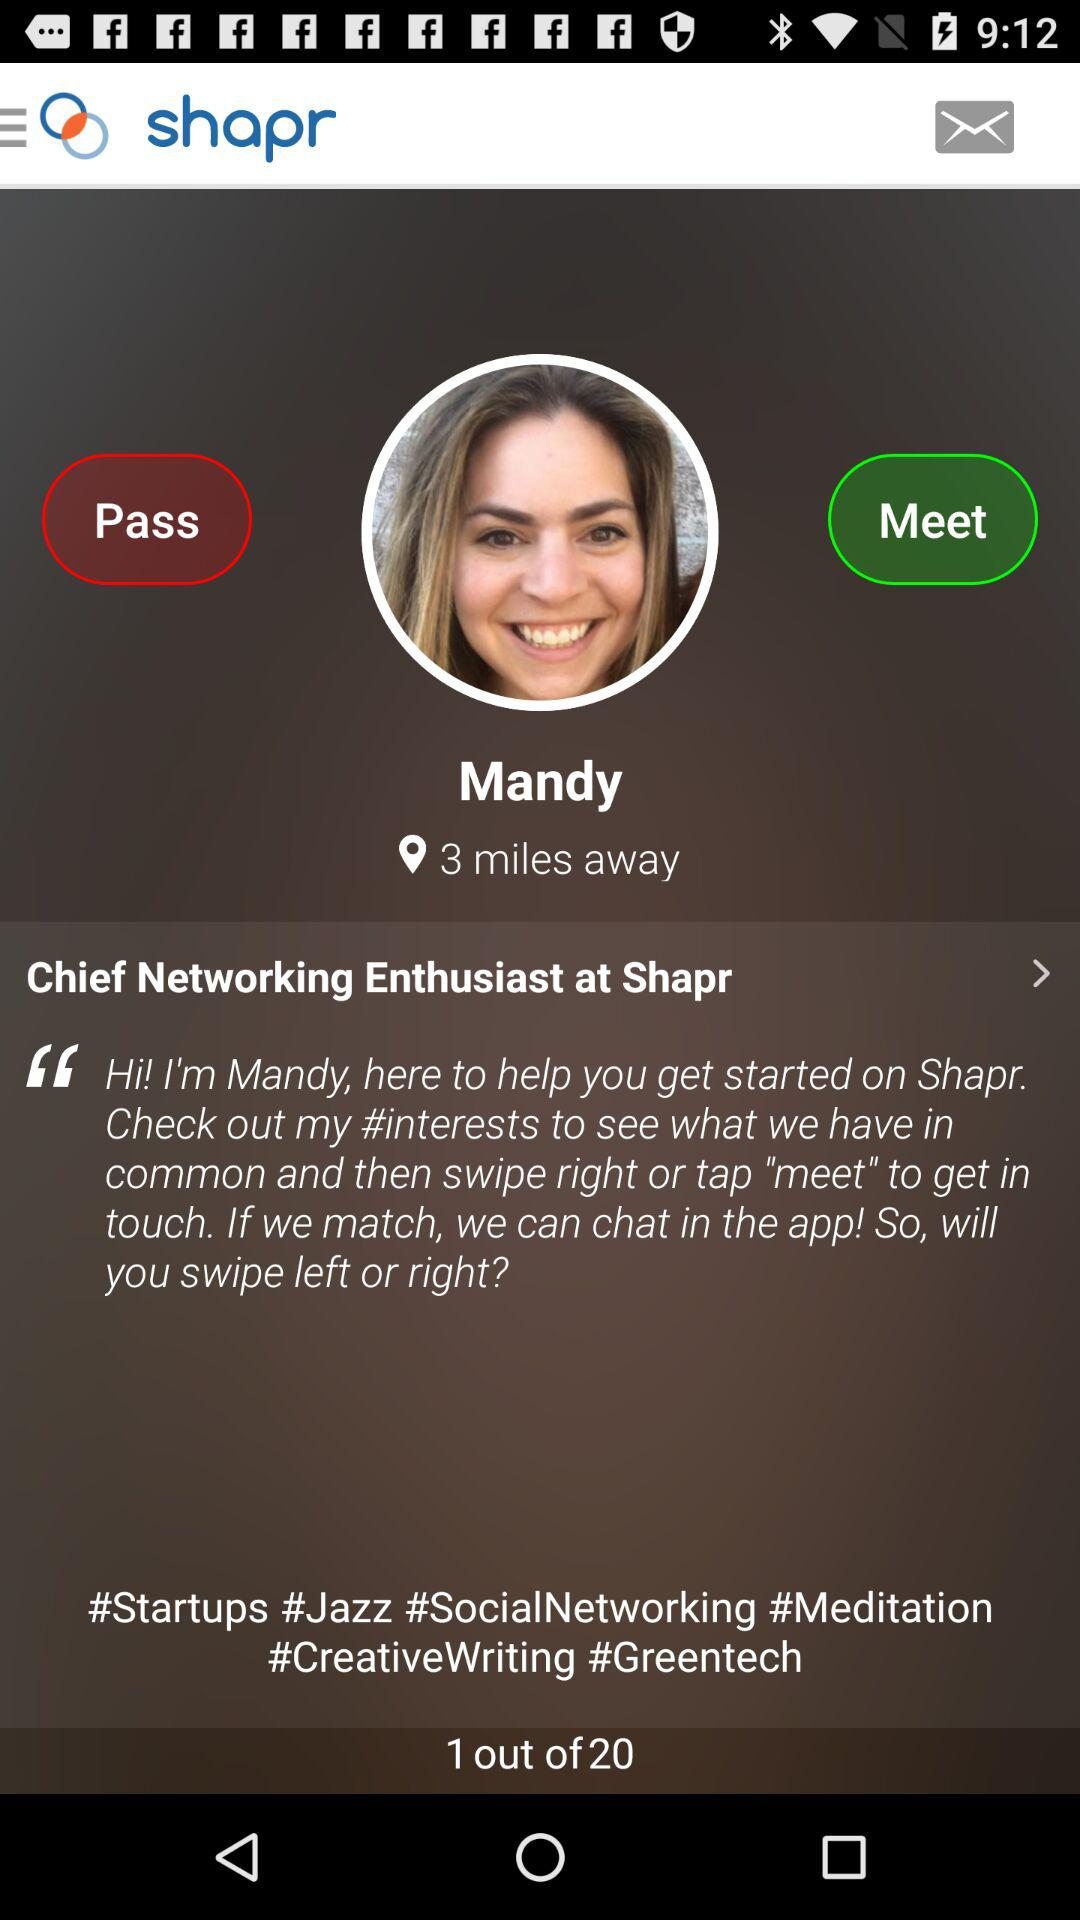What is the number of pages? The number of pages is 20. 